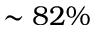<formula> <loc_0><loc_0><loc_500><loc_500>\sim 8 2 \%</formula> 